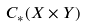Convert formula to latex. <formula><loc_0><loc_0><loc_500><loc_500>C _ { * } ( X \times Y )</formula> 